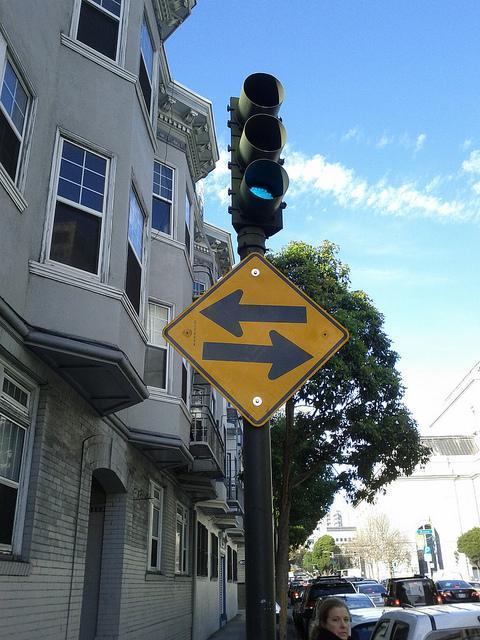How many horses are in this photo?
Give a very brief answer. 0. 